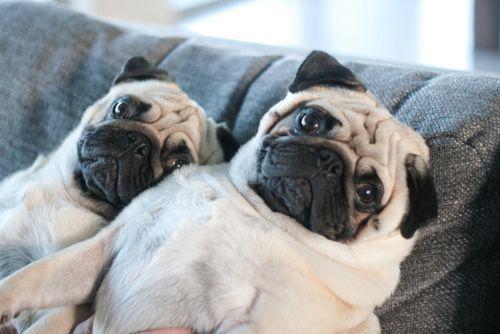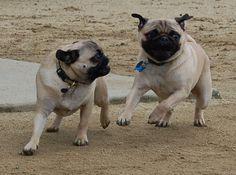The first image is the image on the left, the second image is the image on the right. For the images displayed, is the sentence "There are four dogs." factually correct? Answer yes or no. Yes. The first image is the image on the left, the second image is the image on the right. Analyze the images presented: Is the assertion "One of the pugs shown is black, and the rest are light tan with dark faces." valid? Answer yes or no. No. 